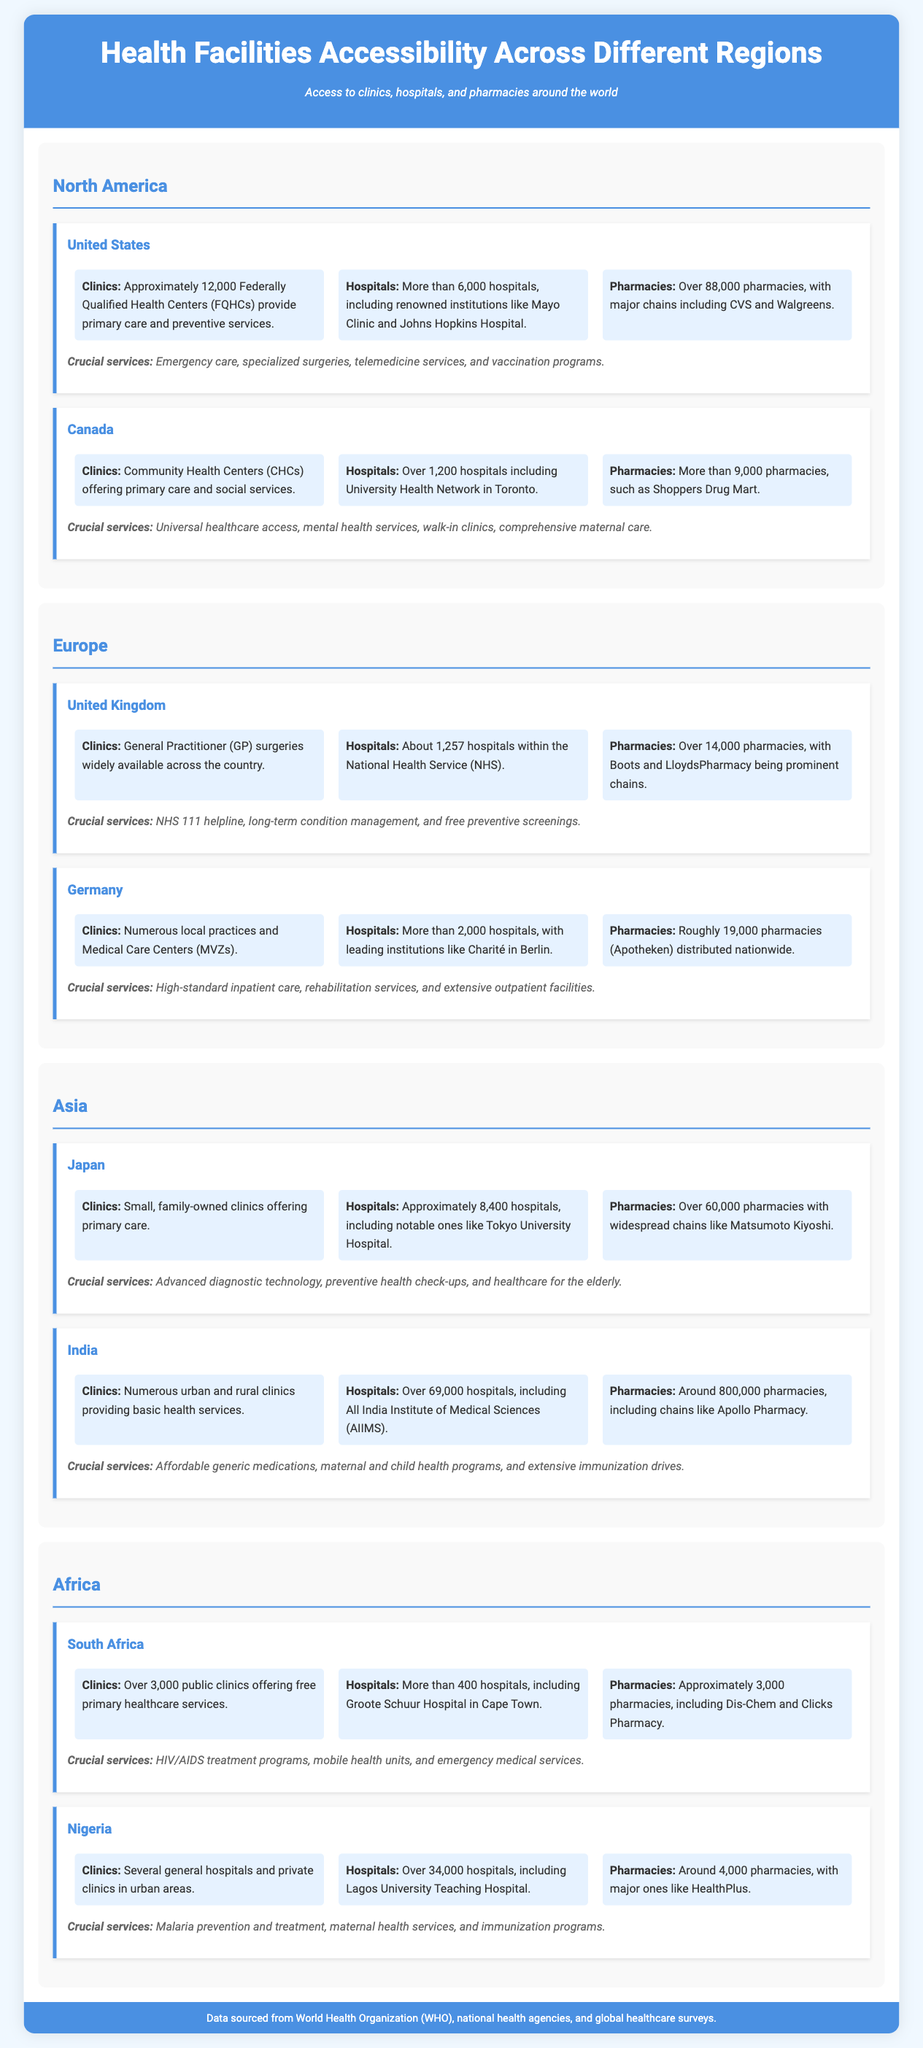What is the number of hospitals in the United States? The document states that there are more than 6,000 hospitals in the United States.
Answer: More than 6,000 How many pharmacies are there in Canada? The document mentions that Canada has more than 9,000 pharmacies.
Answer: More than 9,000 What type of crucial service is emphasized in Germany? The document highlights that Germany provides high-standard inpatient care among its crucial services.
Answer: High-standard inpatient care How many clinics are there in South Africa? According to the document, there are over 3,000 public clinics in South Africa.
Answer: Over 3,000 Which country has the most pharmacies, according to the data? The document states that India has around 800,000 pharmacies, which is the highest number in the data provided.
Answer: Around 800,000 What crucial service is provided in the United Kingdom related to conditions? The document indicates that long-term condition management is a crucial service in the United Kingdom.
Answer: Long-term condition management In which region are the hospitals categorized in this infographic? The document categorizes hospitals under North America, Europe, Asia, and Africa regions.
Answer: North America, Europe, Asia, Africa How many hospitals are listed for Japan? The document lists approximately 8,400 hospitals in Japan.
Answer: Approximately 8,400 What commonality exists in the types of facilities available in all countries mentioned? The document shows that all countries mentioned have access to clinics, hospitals, and pharmacies.
Answer: Clinics, hospitals, pharmacies 